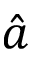Convert formula to latex. <formula><loc_0><loc_0><loc_500><loc_500>\hat { a }</formula> 